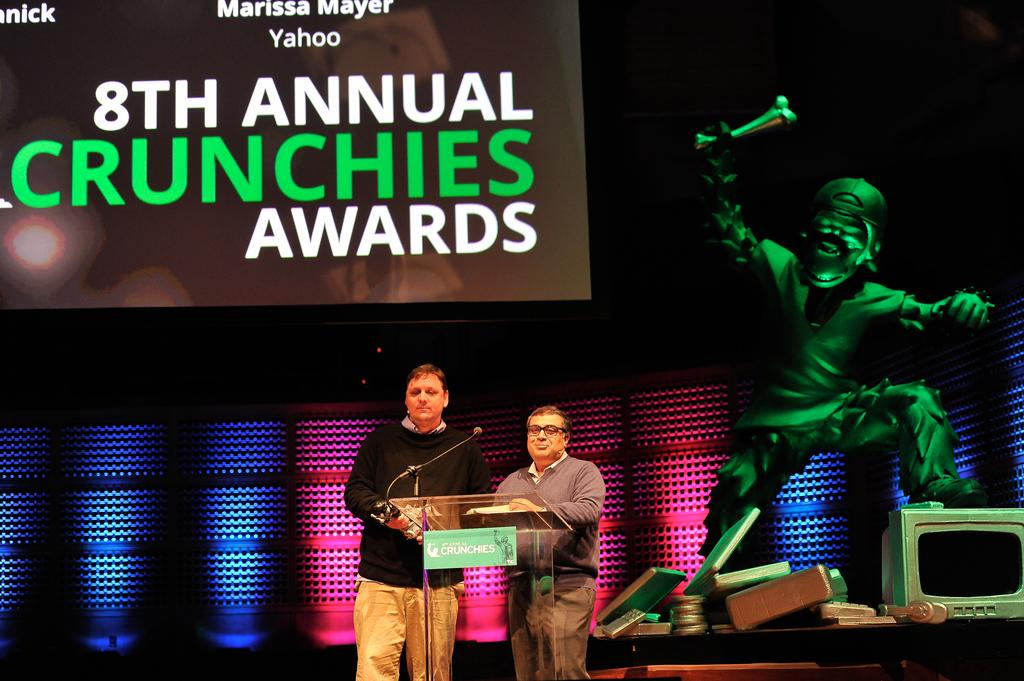<image>
Share a concise interpretation of the image provided. Two men are presenting on stage at an awards show. 